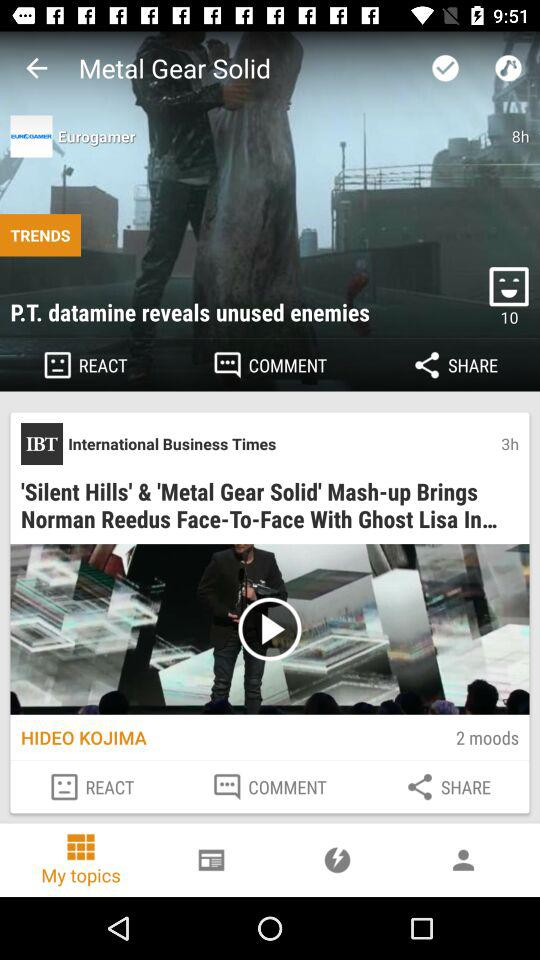How many people reacted? The number of people who reacted is 10. 